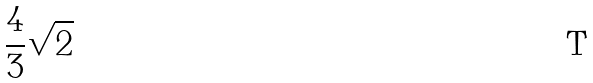<formula> <loc_0><loc_0><loc_500><loc_500>\frac { 4 } { 3 } \sqrt { 2 }</formula> 